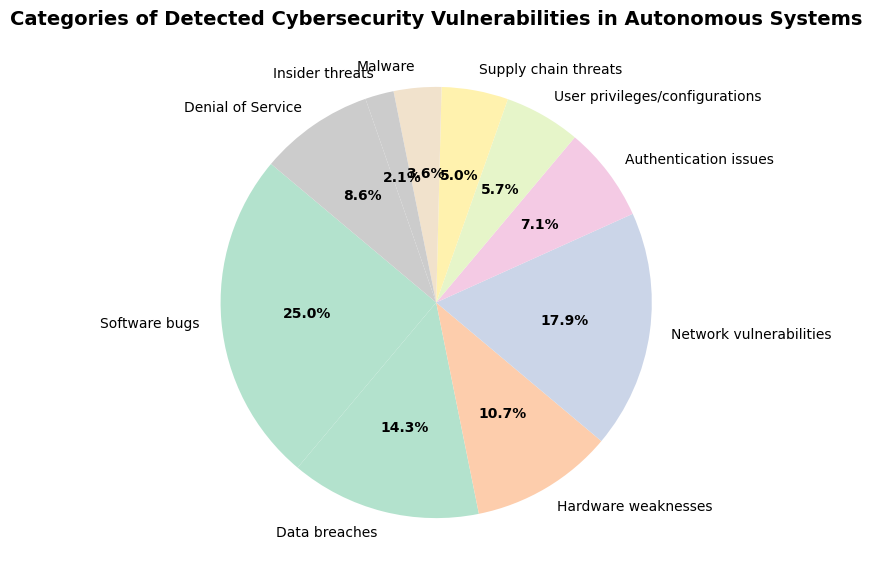What is the category with the highest number of detected cybersecurity vulnerabilities? The category with the highest number is the one with the largest slice in the pie chart, which is "Software bugs."
Answer: Software bugs What is the combined percentage of "Network vulnerabilities" and "Denial of Service"? First, determine the percentage for each category from the pie chart. Network vulnerabilities are 25%, and Denial of Service is 12%. Adding these together gives 25% + 12% = 37%.
Answer: 37% Which category has fewer vulnerabilities: "Hardware weaknesses" or "Data breaches"? By comparing the slices, "Hardware weaknesses" have a smaller count (15) than "Data breaches" (20).
Answer: Hardware weaknesses What is the smallest category of detected cybersecurity vulnerabilities? The smallest slice in the pie chart represents the category with the fewest vulnerabilities, which is "Insider threats."
Answer: Insider threats Are there more vulnerabilities in "User privileges/configurations" or "Supply chain threats"? Comparing their slices, "User privileges/configurations" (8) has more vulnerabilities than "Supply chain threats" (7).
Answer: User privileges/configurations What is the total percentage for categories with counts above 20? Identify the categories with counts above 20: "Software bugs" (35) and "Network vulnerabilities" (25). Determine their percentages as 35% and 25%, then add them together: 35% + 25% = 60%.
Answer: 60% How many more vulnerabilities are there in "Software bugs" than in "Malware"? Subtract the count of "Malware" (5) from the count of "Software bugs" (35): 35 - 5 = 30.
Answer: 30 Which categories have a count that is exactly half of "Software bugs"? Find half of the "Software bugs" count: 35 / 2 = 17.5. No category has a count of exactly 17.5, so none fit this criterion.
Answer: None What is the percentage representation for "Data breaches"? The slice representing "Data breaches" is labeled with its percentage, which is 20%.
Answer: 20% Which categories together cover approximately three-quarters of the vulnerabilities? Calculate the combined percentage of all categories until it reaches approximately 75%. "Software bugs" (35%), "Network vulnerabilities" (25%), and "Data breaches" (20%) together make 35% + 25% + 20% = 80%, which is slightly above three-quarters. Dropping one category, possibly reducing it to "Software bugs" and "Network vulnerabilities", would cover 35% + 25% = 60%, which is below 75%. So we include "Denial of Service" (12%) for 35% + 25% + 12% = 72%.
Answer: Software bugs, Network vulnerabilities, and Denial of Service 